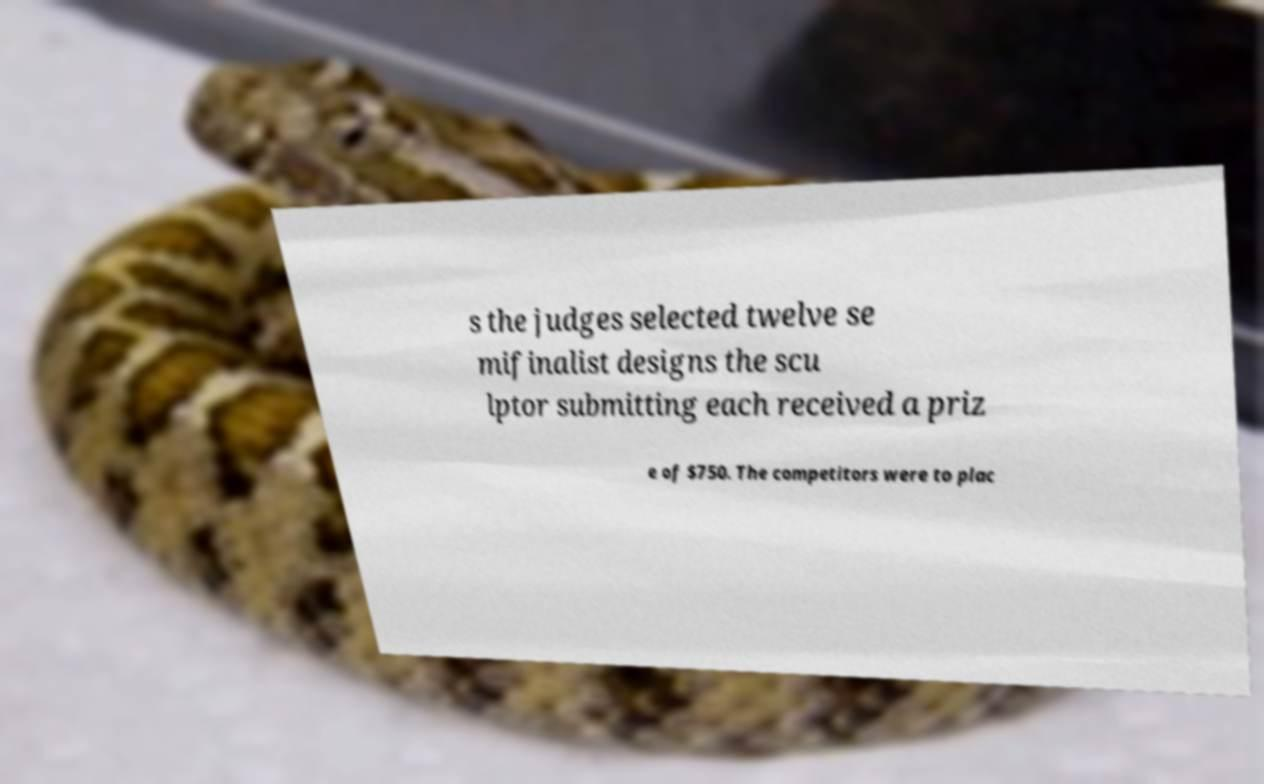Could you extract and type out the text from this image? s the judges selected twelve se mifinalist designs the scu lptor submitting each received a priz e of $750. The competitors were to plac 